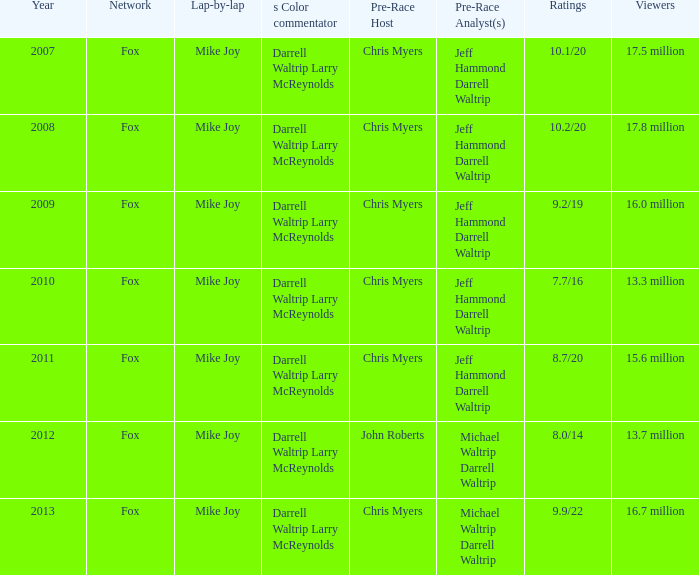Which Network has 17.5 million Viewers? Fox. 